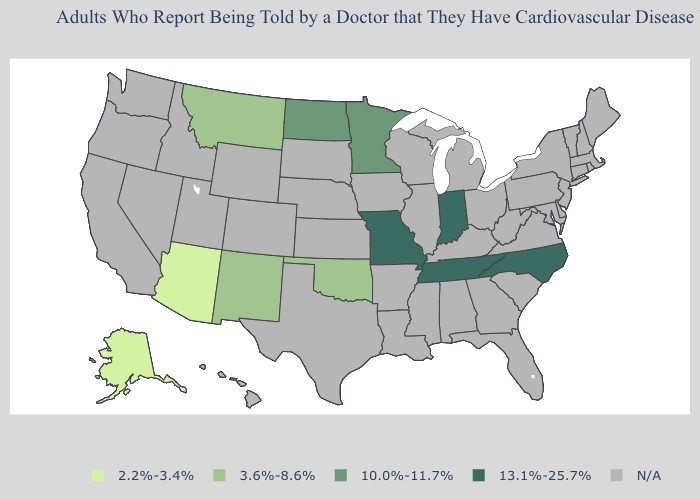Name the states that have a value in the range 13.1%-25.7%?
Be succinct. Indiana, Missouri, North Carolina, Tennessee. What is the value of South Dakota?
Give a very brief answer. N/A. Name the states that have a value in the range 3.6%-8.6%?
Short answer required. Montana, New Mexico, Oklahoma. What is the value of Oregon?
Keep it brief. N/A. How many symbols are there in the legend?
Write a very short answer. 5. What is the lowest value in states that border Virginia?
Short answer required. 13.1%-25.7%. Name the states that have a value in the range 2.2%-3.4%?
Write a very short answer. Alaska, Arizona. Name the states that have a value in the range N/A?
Give a very brief answer. Alabama, Arkansas, California, Colorado, Connecticut, Delaware, Florida, Georgia, Hawaii, Idaho, Illinois, Iowa, Kansas, Kentucky, Louisiana, Maine, Maryland, Massachusetts, Michigan, Mississippi, Nebraska, Nevada, New Hampshire, New Jersey, New York, Ohio, Oregon, Pennsylvania, Rhode Island, South Carolina, South Dakota, Texas, Utah, Vermont, Virginia, Washington, West Virginia, Wisconsin, Wyoming. Which states have the lowest value in the USA?
Keep it brief. Alaska, Arizona. Name the states that have a value in the range 10.0%-11.7%?
Short answer required. Minnesota, North Dakota. Name the states that have a value in the range 3.6%-8.6%?
Write a very short answer. Montana, New Mexico, Oklahoma. What is the lowest value in states that border New Mexico?
Quick response, please. 2.2%-3.4%. Which states have the highest value in the USA?
Keep it brief. Indiana, Missouri, North Carolina, Tennessee. 